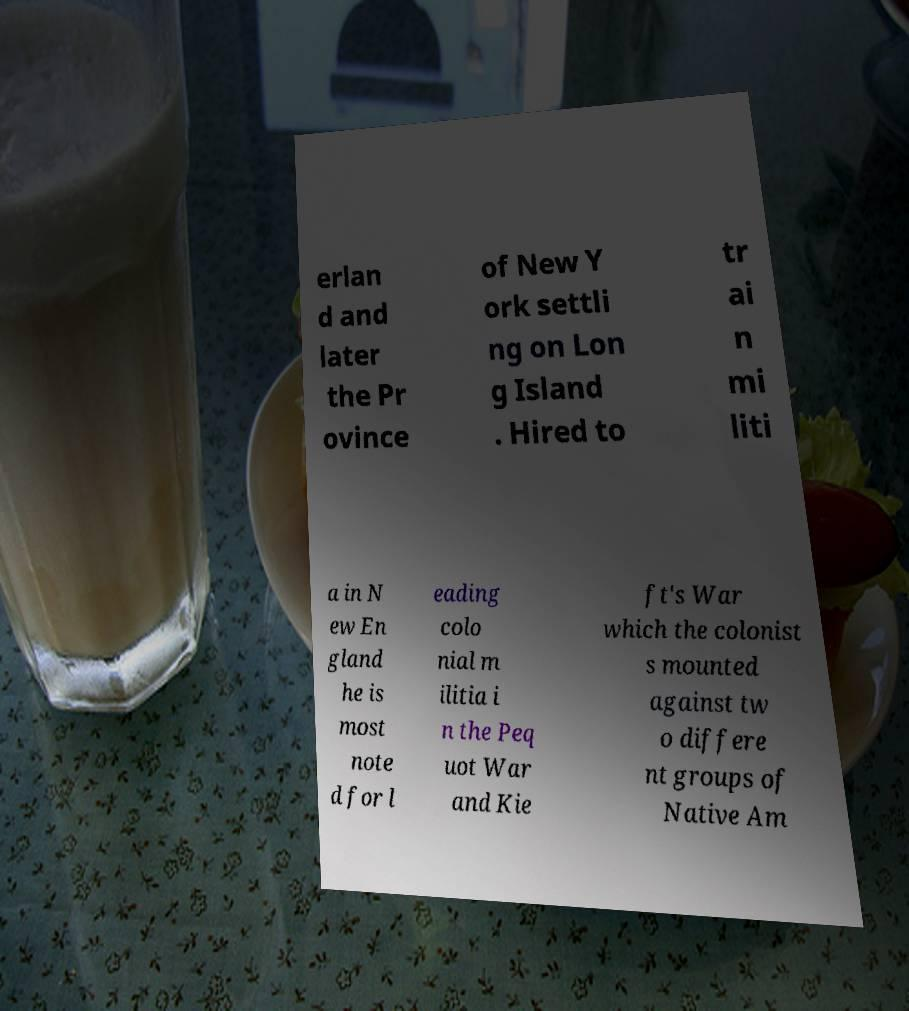Can you accurately transcribe the text from the provided image for me? erlan d and later the Pr ovince of New Y ork settli ng on Lon g Island . Hired to tr ai n mi liti a in N ew En gland he is most note d for l eading colo nial m ilitia i n the Peq uot War and Kie ft's War which the colonist s mounted against tw o differe nt groups of Native Am 